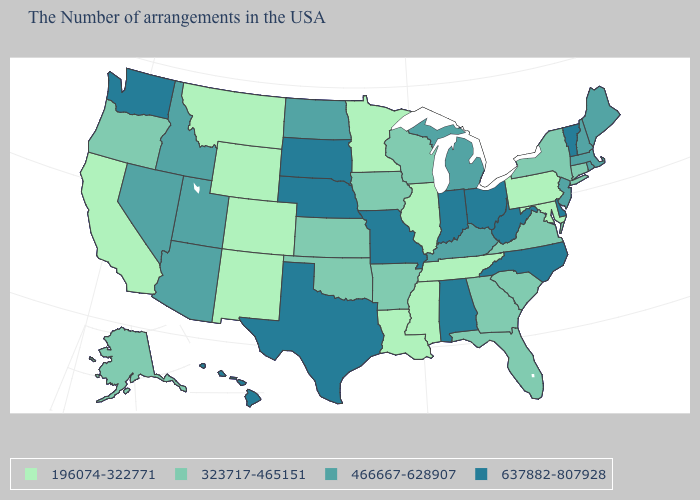Which states have the highest value in the USA?
Short answer required. Vermont, Delaware, North Carolina, West Virginia, Ohio, Indiana, Alabama, Missouri, Nebraska, Texas, South Dakota, Washington, Hawaii. What is the value of Illinois?
Short answer required. 196074-322771. Which states have the lowest value in the MidWest?
Be succinct. Illinois, Minnesota. What is the value of Washington?
Answer briefly. 637882-807928. What is the value of Louisiana?
Short answer required. 196074-322771. What is the value of Missouri?
Quick response, please. 637882-807928. Name the states that have a value in the range 466667-628907?
Write a very short answer. Maine, Massachusetts, Rhode Island, New Hampshire, New Jersey, Michigan, Kentucky, North Dakota, Utah, Arizona, Idaho, Nevada. Does Hawaii have the highest value in the USA?
Quick response, please. Yes. Does the first symbol in the legend represent the smallest category?
Answer briefly. Yes. Name the states that have a value in the range 323717-465151?
Answer briefly. Connecticut, New York, Virginia, South Carolina, Florida, Georgia, Wisconsin, Arkansas, Iowa, Kansas, Oklahoma, Oregon, Alaska. Does Ohio have the same value as Maine?
Be succinct. No. Name the states that have a value in the range 466667-628907?
Quick response, please. Maine, Massachusetts, Rhode Island, New Hampshire, New Jersey, Michigan, Kentucky, North Dakota, Utah, Arizona, Idaho, Nevada. Which states have the highest value in the USA?
Write a very short answer. Vermont, Delaware, North Carolina, West Virginia, Ohio, Indiana, Alabama, Missouri, Nebraska, Texas, South Dakota, Washington, Hawaii. Among the states that border Nebraska , which have the lowest value?
Write a very short answer. Wyoming, Colorado. Does the first symbol in the legend represent the smallest category?
Write a very short answer. Yes. 